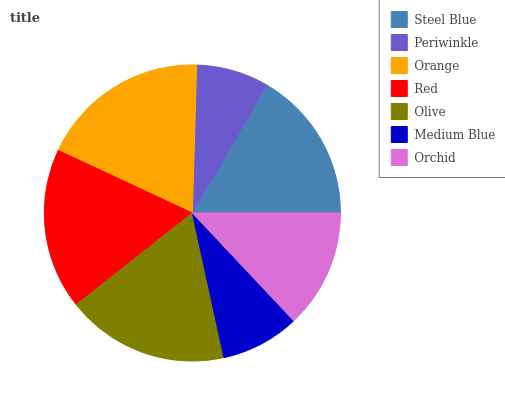Is Periwinkle the minimum?
Answer yes or no. Yes. Is Orange the maximum?
Answer yes or no. Yes. Is Orange the minimum?
Answer yes or no. No. Is Periwinkle the maximum?
Answer yes or no. No. Is Orange greater than Periwinkle?
Answer yes or no. Yes. Is Periwinkle less than Orange?
Answer yes or no. Yes. Is Periwinkle greater than Orange?
Answer yes or no. No. Is Orange less than Periwinkle?
Answer yes or no. No. Is Steel Blue the high median?
Answer yes or no. Yes. Is Steel Blue the low median?
Answer yes or no. Yes. Is Olive the high median?
Answer yes or no. No. Is Medium Blue the low median?
Answer yes or no. No. 